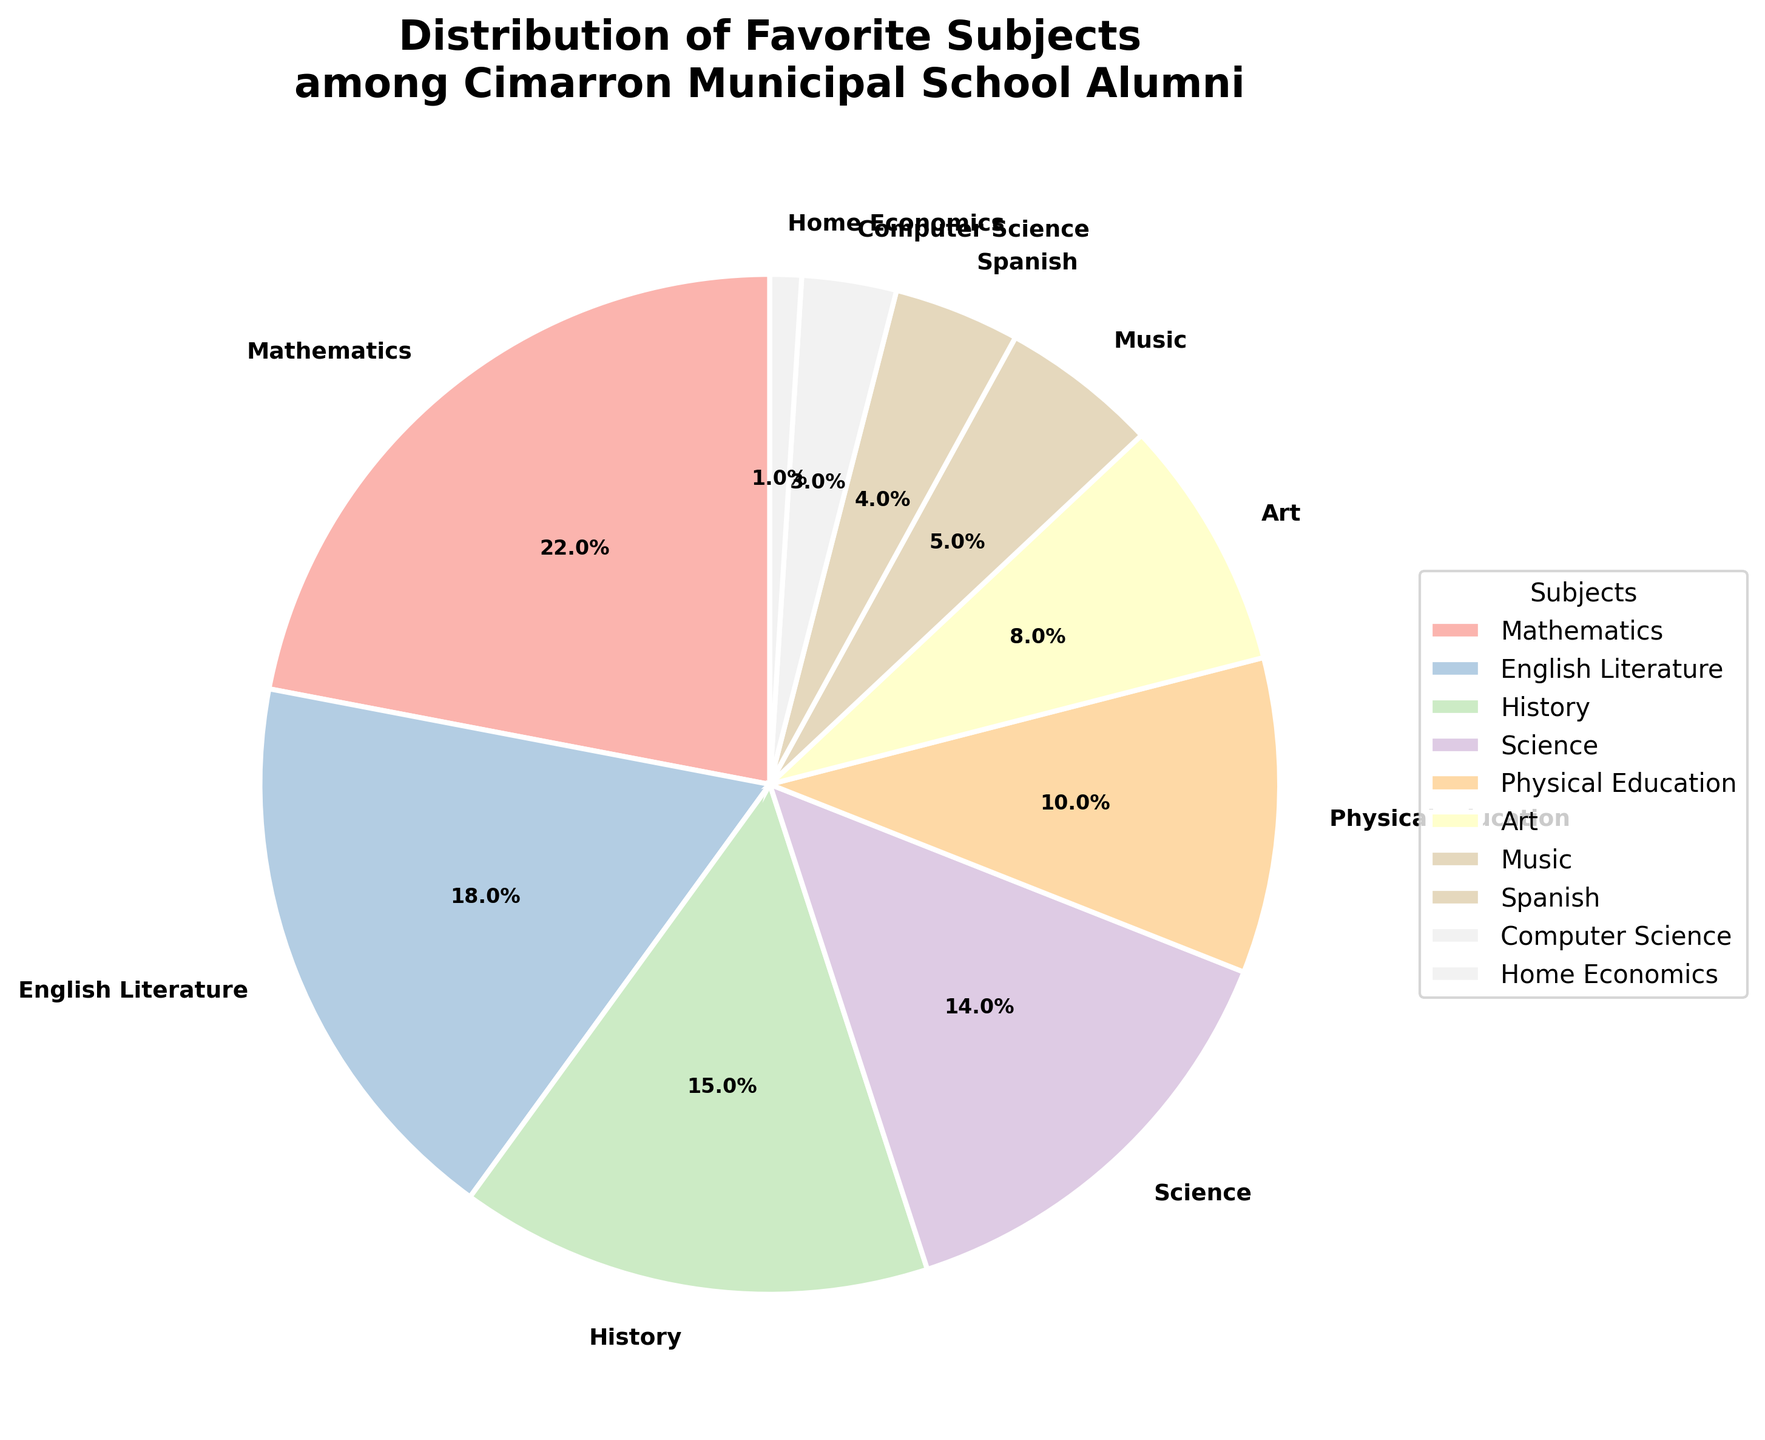What is the favorite subject among Cimarron Municipal School alumni? The pie chart clearly indicates that Mathematics has the largest wedge with a 22% share, making it the favorite subject among the alumni.
Answer: Mathematics What is the combined percentage of alumni whose favorite subjects are Science and English Literature? From the chart, Science has a 14% share and English Literature has an 18% share. Adding these percentages together gives 14% + 18% = 32%.
Answer: 32% How does the percentage of alumni who prefer History compare to those who prefer Physical Education? The chart shows that History has a 15% share while Physical Education has a 10% share. 15% is greater than 10%.
Answer: History has a higher percentage than Physical Education Which subject has the smallest share of alumni preference, and what is its percentage? Home Economics has the smallest wedge on the pie chart, indicating it is the least favorite subject with a 1% share.
Answer: Home Economics, 1% Is the sum of the preferences for Art, Music, and Spanish greater than the preference for Mathematics? From the chart, Art has an 8% share, Music has a 5% share, and Spanish has a 4% share. Adding these gives 8% + 5% + 4% = 17%. Mathematics has a 22% share, so 17% < 22%.
Answer: No, the sum is 17%, which is less than Mathematics' 22% What subject occupies a percentage segment of 10%? The pie chart shows that Physical Education occupies a wedge marked as 10%.
Answer: Physical Education If you combine English Literature, History, and Science, what percentage of alumni do they collectively represent? English Literature is 18%, History is 15%, and Science is 14%. Adding these gives 18% + 15% + 14% = 47%.
Answer: 47% Which two subjects together constitute the same proportion as Mathematics? Physical Education has a 10% share and Art has an 8% share; combined they are 10% + 8% = 18%. To match Mathematics' 22%, adding Music's 5% gives 18% + 5% = 23%, which is very close but not exact. Spanish (4%) combined with History (15%) makes 19%, also close. None are exact, but closest to Math by sum are Music and either Physical Education or Art in approximate terms.
Answer: No exact match, but Music + Physical Education (15%) are closest What is the average percentage of the bottom four least favorite subjects? The bottom four least favorite subjects are Home Economics (1%), Computer Science (3%), Spanish (4%), and Music (5%). Their sum is 1% + 3% + 4% + 5% = 13%. Since there are 4 subjects, 13%/4 = 3.25%.
Answer: 3.25% Which subject shares have a difference of exactly 4% between them? Comparing the chart, English Literature (18%) and Science (14%) have a difference of 4%. Similarly, History (15%) and Physical Education (10%) also have a 5% difference, so not exactly 4%.
Answer: English Literature and Science How many subjects have a preference greater than or equal to 10% among the alumni? According to the pie chart, Mathematics (22%), English Literature (18%), History (15%), Science (14%), and Physical Education (10%) each have a share of 10% or more. There are five such subjects.
Answer: 5 